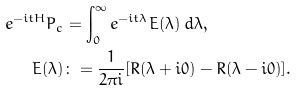Convert formula to latex. <formula><loc_0><loc_0><loc_500><loc_500>e ^ { - i t H } P _ { c } & = \int _ { 0 } ^ { \infty } e ^ { - i t \lambda } E ( \lambda ) \, d \lambda , \\ E ( \lambda ) & \colon = \frac { 1 } { 2 \pi i } [ R ( \lambda + i 0 ) - R ( \lambda - i 0 ) ] .</formula> 